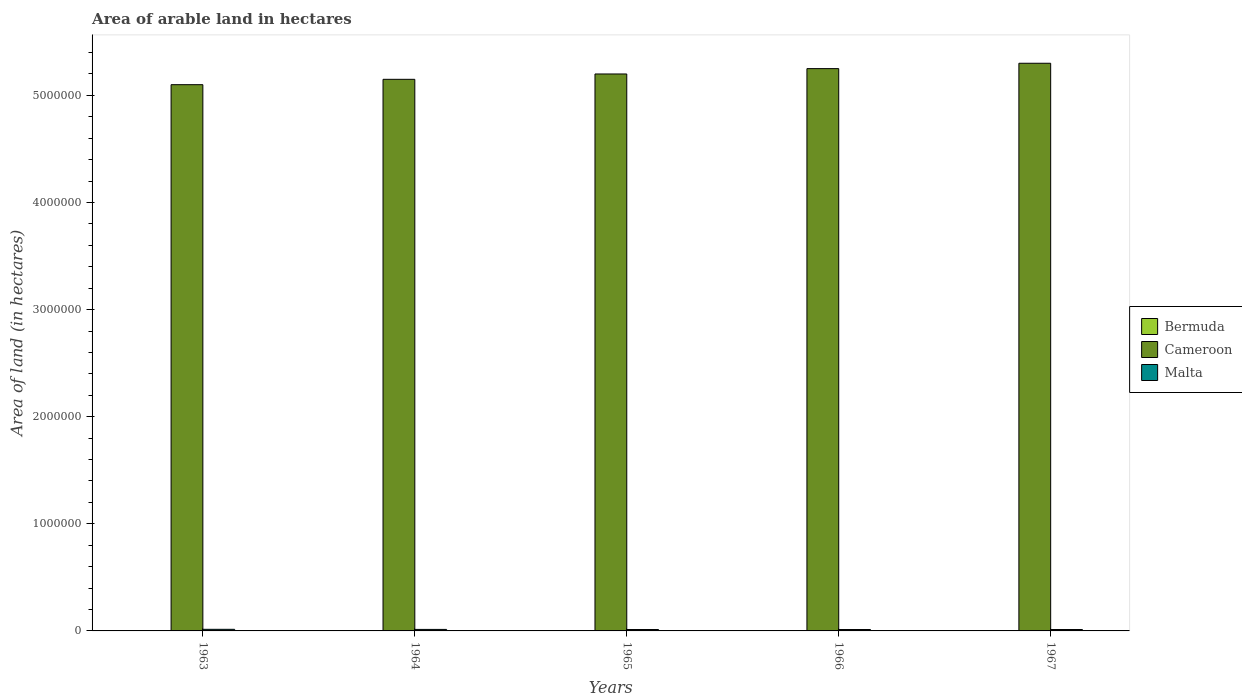How many different coloured bars are there?
Your answer should be compact. 3. Are the number of bars on each tick of the X-axis equal?
Offer a terse response. Yes. How many bars are there on the 1st tick from the left?
Provide a succinct answer. 3. What is the label of the 2nd group of bars from the left?
Provide a succinct answer. 1964. What is the total arable land in Bermuda in 1967?
Offer a very short reply. 400. Across all years, what is the maximum total arable land in Cameroon?
Offer a terse response. 5.30e+06. Across all years, what is the minimum total arable land in Malta?
Keep it short and to the point. 1.30e+04. In which year was the total arable land in Malta maximum?
Make the answer very short. 1963. In which year was the total arable land in Bermuda minimum?
Give a very brief answer. 1963. What is the total total arable land in Cameroon in the graph?
Make the answer very short. 2.60e+07. What is the difference between the total arable land in Bermuda in 1963 and that in 1967?
Ensure brevity in your answer.  -100. What is the difference between the total arable land in Malta in 1964 and the total arable land in Cameroon in 1967?
Provide a succinct answer. -5.29e+06. What is the average total arable land in Bermuda per year?
Provide a short and direct response. 380. In the year 1964, what is the difference between the total arable land in Bermuda and total arable land in Cameroon?
Offer a terse response. -5.15e+06. What is the ratio of the total arable land in Cameroon in 1963 to that in 1965?
Make the answer very short. 0.98. Is the total arable land in Malta in 1963 less than that in 1967?
Make the answer very short. No. Is the difference between the total arable land in Bermuda in 1965 and 1966 greater than the difference between the total arable land in Cameroon in 1965 and 1966?
Offer a terse response. Yes. What is the difference between the highest and the second highest total arable land in Malta?
Offer a very short reply. 1000. What is the difference between the highest and the lowest total arable land in Cameroon?
Offer a terse response. 2.00e+05. Is the sum of the total arable land in Cameroon in 1964 and 1966 greater than the maximum total arable land in Bermuda across all years?
Provide a succinct answer. Yes. What does the 1st bar from the left in 1965 represents?
Your answer should be compact. Bermuda. What does the 2nd bar from the right in 1965 represents?
Your response must be concise. Cameroon. Is it the case that in every year, the sum of the total arable land in Malta and total arable land in Bermuda is greater than the total arable land in Cameroon?
Provide a short and direct response. No. How many bars are there?
Offer a terse response. 15. Are all the bars in the graph horizontal?
Keep it short and to the point. No. How many years are there in the graph?
Keep it short and to the point. 5. Are the values on the major ticks of Y-axis written in scientific E-notation?
Your answer should be compact. No. Does the graph contain any zero values?
Ensure brevity in your answer.  No. Does the graph contain grids?
Keep it short and to the point. No. Where does the legend appear in the graph?
Provide a short and direct response. Center right. What is the title of the graph?
Provide a short and direct response. Area of arable land in hectares. Does "Congo (Republic)" appear as one of the legend labels in the graph?
Provide a short and direct response. No. What is the label or title of the X-axis?
Offer a terse response. Years. What is the label or title of the Y-axis?
Your response must be concise. Area of land (in hectares). What is the Area of land (in hectares) of Bermuda in 1963?
Your answer should be very brief. 300. What is the Area of land (in hectares) of Cameroon in 1963?
Offer a very short reply. 5.10e+06. What is the Area of land (in hectares) of Malta in 1963?
Keep it short and to the point. 1.50e+04. What is the Area of land (in hectares) in Bermuda in 1964?
Your answer should be very brief. 400. What is the Area of land (in hectares) of Cameroon in 1964?
Your answer should be compact. 5.15e+06. What is the Area of land (in hectares) in Malta in 1964?
Your response must be concise. 1.40e+04. What is the Area of land (in hectares) of Bermuda in 1965?
Your answer should be very brief. 400. What is the Area of land (in hectares) in Cameroon in 1965?
Offer a very short reply. 5.20e+06. What is the Area of land (in hectares) in Malta in 1965?
Your answer should be very brief. 1.30e+04. What is the Area of land (in hectares) of Bermuda in 1966?
Your answer should be compact. 400. What is the Area of land (in hectares) in Cameroon in 1966?
Your answer should be very brief. 5.25e+06. What is the Area of land (in hectares) of Malta in 1966?
Offer a terse response. 1.30e+04. What is the Area of land (in hectares) in Cameroon in 1967?
Offer a terse response. 5.30e+06. What is the Area of land (in hectares) in Malta in 1967?
Provide a succinct answer. 1.30e+04. Across all years, what is the maximum Area of land (in hectares) in Bermuda?
Provide a short and direct response. 400. Across all years, what is the maximum Area of land (in hectares) in Cameroon?
Keep it short and to the point. 5.30e+06. Across all years, what is the maximum Area of land (in hectares) in Malta?
Make the answer very short. 1.50e+04. Across all years, what is the minimum Area of land (in hectares) of Bermuda?
Your answer should be compact. 300. Across all years, what is the minimum Area of land (in hectares) in Cameroon?
Provide a succinct answer. 5.10e+06. Across all years, what is the minimum Area of land (in hectares) in Malta?
Provide a succinct answer. 1.30e+04. What is the total Area of land (in hectares) of Bermuda in the graph?
Provide a succinct answer. 1900. What is the total Area of land (in hectares) in Cameroon in the graph?
Your response must be concise. 2.60e+07. What is the total Area of land (in hectares) of Malta in the graph?
Offer a very short reply. 6.80e+04. What is the difference between the Area of land (in hectares) in Bermuda in 1963 and that in 1964?
Your answer should be very brief. -100. What is the difference between the Area of land (in hectares) of Bermuda in 1963 and that in 1965?
Make the answer very short. -100. What is the difference between the Area of land (in hectares) in Bermuda in 1963 and that in 1966?
Provide a short and direct response. -100. What is the difference between the Area of land (in hectares) of Cameroon in 1963 and that in 1966?
Ensure brevity in your answer.  -1.50e+05. What is the difference between the Area of land (in hectares) of Malta in 1963 and that in 1966?
Provide a succinct answer. 2000. What is the difference between the Area of land (in hectares) in Bermuda in 1963 and that in 1967?
Your response must be concise. -100. What is the difference between the Area of land (in hectares) of Cameroon in 1963 and that in 1967?
Your response must be concise. -2.00e+05. What is the difference between the Area of land (in hectares) of Malta in 1963 and that in 1967?
Give a very brief answer. 2000. What is the difference between the Area of land (in hectares) of Bermuda in 1964 and that in 1965?
Ensure brevity in your answer.  0. What is the difference between the Area of land (in hectares) of Cameroon in 1964 and that in 1965?
Your response must be concise. -5.00e+04. What is the difference between the Area of land (in hectares) in Bermuda in 1964 and that in 1966?
Ensure brevity in your answer.  0. What is the difference between the Area of land (in hectares) of Bermuda in 1964 and that in 1967?
Make the answer very short. 0. What is the difference between the Area of land (in hectares) of Cameroon in 1964 and that in 1967?
Ensure brevity in your answer.  -1.50e+05. What is the difference between the Area of land (in hectares) in Malta in 1964 and that in 1967?
Provide a succinct answer. 1000. What is the difference between the Area of land (in hectares) of Cameroon in 1965 and that in 1966?
Keep it short and to the point. -5.00e+04. What is the difference between the Area of land (in hectares) of Malta in 1965 and that in 1966?
Keep it short and to the point. 0. What is the difference between the Area of land (in hectares) in Bermuda in 1966 and that in 1967?
Make the answer very short. 0. What is the difference between the Area of land (in hectares) of Cameroon in 1966 and that in 1967?
Offer a terse response. -5.00e+04. What is the difference between the Area of land (in hectares) of Malta in 1966 and that in 1967?
Your answer should be very brief. 0. What is the difference between the Area of land (in hectares) of Bermuda in 1963 and the Area of land (in hectares) of Cameroon in 1964?
Ensure brevity in your answer.  -5.15e+06. What is the difference between the Area of land (in hectares) in Bermuda in 1963 and the Area of land (in hectares) in Malta in 1964?
Your response must be concise. -1.37e+04. What is the difference between the Area of land (in hectares) of Cameroon in 1963 and the Area of land (in hectares) of Malta in 1964?
Make the answer very short. 5.09e+06. What is the difference between the Area of land (in hectares) in Bermuda in 1963 and the Area of land (in hectares) in Cameroon in 1965?
Your answer should be compact. -5.20e+06. What is the difference between the Area of land (in hectares) of Bermuda in 1963 and the Area of land (in hectares) of Malta in 1965?
Your answer should be compact. -1.27e+04. What is the difference between the Area of land (in hectares) of Cameroon in 1963 and the Area of land (in hectares) of Malta in 1965?
Make the answer very short. 5.09e+06. What is the difference between the Area of land (in hectares) of Bermuda in 1963 and the Area of land (in hectares) of Cameroon in 1966?
Your answer should be very brief. -5.25e+06. What is the difference between the Area of land (in hectares) in Bermuda in 1963 and the Area of land (in hectares) in Malta in 1966?
Keep it short and to the point. -1.27e+04. What is the difference between the Area of land (in hectares) in Cameroon in 1963 and the Area of land (in hectares) in Malta in 1966?
Your answer should be compact. 5.09e+06. What is the difference between the Area of land (in hectares) in Bermuda in 1963 and the Area of land (in hectares) in Cameroon in 1967?
Your answer should be very brief. -5.30e+06. What is the difference between the Area of land (in hectares) in Bermuda in 1963 and the Area of land (in hectares) in Malta in 1967?
Provide a succinct answer. -1.27e+04. What is the difference between the Area of land (in hectares) in Cameroon in 1963 and the Area of land (in hectares) in Malta in 1967?
Make the answer very short. 5.09e+06. What is the difference between the Area of land (in hectares) of Bermuda in 1964 and the Area of land (in hectares) of Cameroon in 1965?
Give a very brief answer. -5.20e+06. What is the difference between the Area of land (in hectares) in Bermuda in 1964 and the Area of land (in hectares) in Malta in 1965?
Your answer should be compact. -1.26e+04. What is the difference between the Area of land (in hectares) of Cameroon in 1964 and the Area of land (in hectares) of Malta in 1965?
Your answer should be very brief. 5.14e+06. What is the difference between the Area of land (in hectares) of Bermuda in 1964 and the Area of land (in hectares) of Cameroon in 1966?
Offer a terse response. -5.25e+06. What is the difference between the Area of land (in hectares) in Bermuda in 1964 and the Area of land (in hectares) in Malta in 1966?
Your response must be concise. -1.26e+04. What is the difference between the Area of land (in hectares) of Cameroon in 1964 and the Area of land (in hectares) of Malta in 1966?
Provide a short and direct response. 5.14e+06. What is the difference between the Area of land (in hectares) of Bermuda in 1964 and the Area of land (in hectares) of Cameroon in 1967?
Ensure brevity in your answer.  -5.30e+06. What is the difference between the Area of land (in hectares) of Bermuda in 1964 and the Area of land (in hectares) of Malta in 1967?
Ensure brevity in your answer.  -1.26e+04. What is the difference between the Area of land (in hectares) of Cameroon in 1964 and the Area of land (in hectares) of Malta in 1967?
Offer a very short reply. 5.14e+06. What is the difference between the Area of land (in hectares) of Bermuda in 1965 and the Area of land (in hectares) of Cameroon in 1966?
Offer a terse response. -5.25e+06. What is the difference between the Area of land (in hectares) in Bermuda in 1965 and the Area of land (in hectares) in Malta in 1966?
Keep it short and to the point. -1.26e+04. What is the difference between the Area of land (in hectares) of Cameroon in 1965 and the Area of land (in hectares) of Malta in 1966?
Offer a very short reply. 5.19e+06. What is the difference between the Area of land (in hectares) of Bermuda in 1965 and the Area of land (in hectares) of Cameroon in 1967?
Your answer should be compact. -5.30e+06. What is the difference between the Area of land (in hectares) in Bermuda in 1965 and the Area of land (in hectares) in Malta in 1967?
Keep it short and to the point. -1.26e+04. What is the difference between the Area of land (in hectares) of Cameroon in 1965 and the Area of land (in hectares) of Malta in 1967?
Offer a terse response. 5.19e+06. What is the difference between the Area of land (in hectares) in Bermuda in 1966 and the Area of land (in hectares) in Cameroon in 1967?
Your response must be concise. -5.30e+06. What is the difference between the Area of land (in hectares) in Bermuda in 1966 and the Area of land (in hectares) in Malta in 1967?
Provide a short and direct response. -1.26e+04. What is the difference between the Area of land (in hectares) in Cameroon in 1966 and the Area of land (in hectares) in Malta in 1967?
Give a very brief answer. 5.24e+06. What is the average Area of land (in hectares) of Bermuda per year?
Your answer should be very brief. 380. What is the average Area of land (in hectares) of Cameroon per year?
Your answer should be compact. 5.20e+06. What is the average Area of land (in hectares) in Malta per year?
Offer a very short reply. 1.36e+04. In the year 1963, what is the difference between the Area of land (in hectares) of Bermuda and Area of land (in hectares) of Cameroon?
Make the answer very short. -5.10e+06. In the year 1963, what is the difference between the Area of land (in hectares) of Bermuda and Area of land (in hectares) of Malta?
Provide a succinct answer. -1.47e+04. In the year 1963, what is the difference between the Area of land (in hectares) in Cameroon and Area of land (in hectares) in Malta?
Give a very brief answer. 5.08e+06. In the year 1964, what is the difference between the Area of land (in hectares) in Bermuda and Area of land (in hectares) in Cameroon?
Your response must be concise. -5.15e+06. In the year 1964, what is the difference between the Area of land (in hectares) in Bermuda and Area of land (in hectares) in Malta?
Offer a terse response. -1.36e+04. In the year 1964, what is the difference between the Area of land (in hectares) in Cameroon and Area of land (in hectares) in Malta?
Your answer should be very brief. 5.14e+06. In the year 1965, what is the difference between the Area of land (in hectares) in Bermuda and Area of land (in hectares) in Cameroon?
Give a very brief answer. -5.20e+06. In the year 1965, what is the difference between the Area of land (in hectares) of Bermuda and Area of land (in hectares) of Malta?
Ensure brevity in your answer.  -1.26e+04. In the year 1965, what is the difference between the Area of land (in hectares) of Cameroon and Area of land (in hectares) of Malta?
Offer a terse response. 5.19e+06. In the year 1966, what is the difference between the Area of land (in hectares) of Bermuda and Area of land (in hectares) of Cameroon?
Make the answer very short. -5.25e+06. In the year 1966, what is the difference between the Area of land (in hectares) in Bermuda and Area of land (in hectares) in Malta?
Make the answer very short. -1.26e+04. In the year 1966, what is the difference between the Area of land (in hectares) of Cameroon and Area of land (in hectares) of Malta?
Your response must be concise. 5.24e+06. In the year 1967, what is the difference between the Area of land (in hectares) of Bermuda and Area of land (in hectares) of Cameroon?
Offer a terse response. -5.30e+06. In the year 1967, what is the difference between the Area of land (in hectares) in Bermuda and Area of land (in hectares) in Malta?
Give a very brief answer. -1.26e+04. In the year 1967, what is the difference between the Area of land (in hectares) in Cameroon and Area of land (in hectares) in Malta?
Provide a short and direct response. 5.29e+06. What is the ratio of the Area of land (in hectares) of Bermuda in 1963 to that in 1964?
Offer a terse response. 0.75. What is the ratio of the Area of land (in hectares) of Cameroon in 1963 to that in 1964?
Your response must be concise. 0.99. What is the ratio of the Area of land (in hectares) in Malta in 1963 to that in 1964?
Provide a short and direct response. 1.07. What is the ratio of the Area of land (in hectares) in Cameroon in 1963 to that in 1965?
Make the answer very short. 0.98. What is the ratio of the Area of land (in hectares) in Malta in 1963 to that in 1965?
Offer a very short reply. 1.15. What is the ratio of the Area of land (in hectares) of Bermuda in 1963 to that in 1966?
Your answer should be very brief. 0.75. What is the ratio of the Area of land (in hectares) in Cameroon in 1963 to that in 1966?
Ensure brevity in your answer.  0.97. What is the ratio of the Area of land (in hectares) in Malta in 1963 to that in 1966?
Provide a short and direct response. 1.15. What is the ratio of the Area of land (in hectares) in Bermuda in 1963 to that in 1967?
Give a very brief answer. 0.75. What is the ratio of the Area of land (in hectares) in Cameroon in 1963 to that in 1967?
Make the answer very short. 0.96. What is the ratio of the Area of land (in hectares) of Malta in 1963 to that in 1967?
Your response must be concise. 1.15. What is the ratio of the Area of land (in hectares) in Malta in 1964 to that in 1965?
Make the answer very short. 1.08. What is the ratio of the Area of land (in hectares) in Malta in 1964 to that in 1966?
Provide a succinct answer. 1.08. What is the ratio of the Area of land (in hectares) of Bermuda in 1964 to that in 1967?
Keep it short and to the point. 1. What is the ratio of the Area of land (in hectares) in Cameroon in 1964 to that in 1967?
Provide a short and direct response. 0.97. What is the ratio of the Area of land (in hectares) of Malta in 1965 to that in 1966?
Your answer should be very brief. 1. What is the ratio of the Area of land (in hectares) of Bermuda in 1965 to that in 1967?
Provide a short and direct response. 1. What is the ratio of the Area of land (in hectares) in Cameroon in 1965 to that in 1967?
Your answer should be very brief. 0.98. What is the ratio of the Area of land (in hectares) in Cameroon in 1966 to that in 1967?
Your answer should be very brief. 0.99. What is the difference between the highest and the second highest Area of land (in hectares) in Bermuda?
Provide a short and direct response. 0. What is the difference between the highest and the second highest Area of land (in hectares) of Cameroon?
Give a very brief answer. 5.00e+04. What is the difference between the highest and the second highest Area of land (in hectares) in Malta?
Your response must be concise. 1000. 